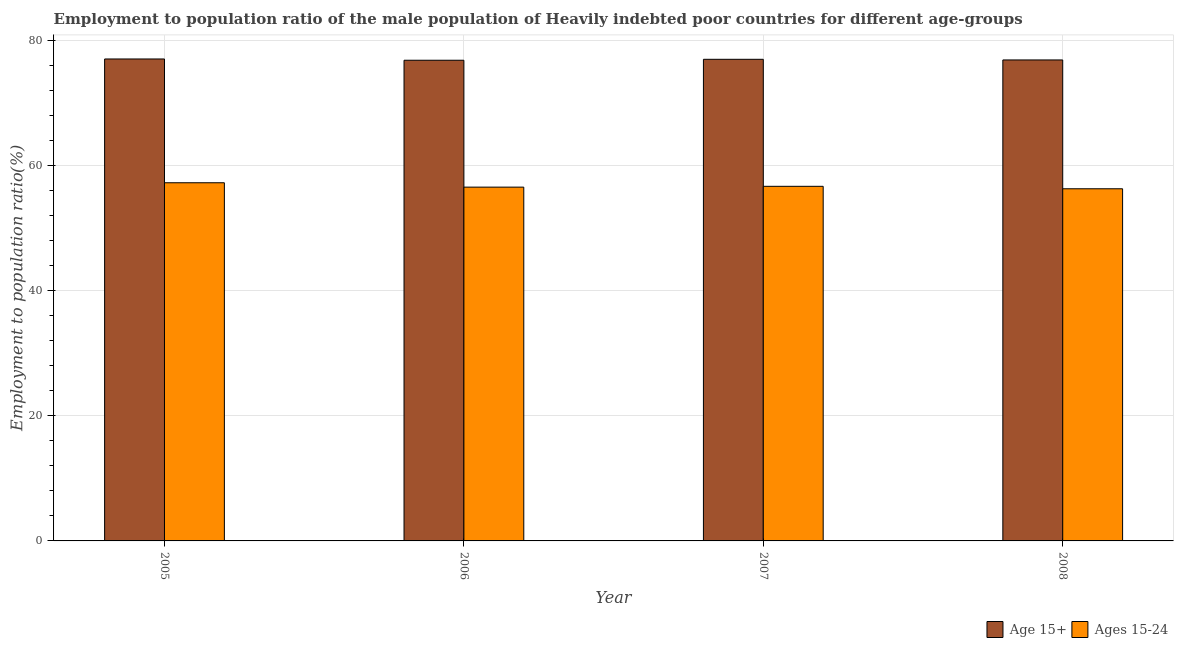Are the number of bars on each tick of the X-axis equal?
Keep it short and to the point. Yes. What is the employment to population ratio(age 15-24) in 2007?
Keep it short and to the point. 56.68. Across all years, what is the maximum employment to population ratio(age 15-24)?
Offer a very short reply. 57.25. Across all years, what is the minimum employment to population ratio(age 15-24)?
Offer a very short reply. 56.28. What is the total employment to population ratio(age 15+) in the graph?
Your answer should be compact. 307.71. What is the difference between the employment to population ratio(age 15+) in 2006 and that in 2008?
Your answer should be compact. -0.05. What is the difference between the employment to population ratio(age 15+) in 2008 and the employment to population ratio(age 15-24) in 2007?
Offer a very short reply. -0.1. What is the average employment to population ratio(age 15+) per year?
Offer a very short reply. 76.93. In the year 2005, what is the difference between the employment to population ratio(age 15+) and employment to population ratio(age 15-24)?
Keep it short and to the point. 0. What is the ratio of the employment to population ratio(age 15-24) in 2005 to that in 2008?
Your answer should be compact. 1.02. Is the difference between the employment to population ratio(age 15+) in 2006 and 2008 greater than the difference between the employment to population ratio(age 15-24) in 2006 and 2008?
Provide a succinct answer. No. What is the difference between the highest and the second highest employment to population ratio(age 15-24)?
Keep it short and to the point. 0.57. What is the difference between the highest and the lowest employment to population ratio(age 15-24)?
Ensure brevity in your answer.  0.96. What does the 1st bar from the left in 2007 represents?
Your answer should be very brief. Age 15+. What does the 1st bar from the right in 2006 represents?
Your answer should be compact. Ages 15-24. How many years are there in the graph?
Provide a succinct answer. 4. What is the difference between two consecutive major ticks on the Y-axis?
Make the answer very short. 20. Are the values on the major ticks of Y-axis written in scientific E-notation?
Offer a terse response. No. Does the graph contain any zero values?
Keep it short and to the point. No. Does the graph contain grids?
Keep it short and to the point. Yes. How are the legend labels stacked?
Offer a terse response. Horizontal. What is the title of the graph?
Make the answer very short. Employment to population ratio of the male population of Heavily indebted poor countries for different age-groups. What is the label or title of the Y-axis?
Your response must be concise. Employment to population ratio(%). What is the Employment to population ratio(%) of Age 15+ in 2005?
Ensure brevity in your answer.  77.03. What is the Employment to population ratio(%) of Ages 15-24 in 2005?
Provide a succinct answer. 57.25. What is the Employment to population ratio(%) of Age 15+ in 2006?
Give a very brief answer. 76.83. What is the Employment to population ratio(%) of Ages 15-24 in 2006?
Give a very brief answer. 56.55. What is the Employment to population ratio(%) in Age 15+ in 2007?
Keep it short and to the point. 76.98. What is the Employment to population ratio(%) in Ages 15-24 in 2007?
Offer a terse response. 56.68. What is the Employment to population ratio(%) in Age 15+ in 2008?
Offer a terse response. 76.87. What is the Employment to population ratio(%) of Ages 15-24 in 2008?
Offer a very short reply. 56.28. Across all years, what is the maximum Employment to population ratio(%) in Age 15+?
Offer a terse response. 77.03. Across all years, what is the maximum Employment to population ratio(%) of Ages 15-24?
Make the answer very short. 57.25. Across all years, what is the minimum Employment to population ratio(%) of Age 15+?
Give a very brief answer. 76.83. Across all years, what is the minimum Employment to population ratio(%) of Ages 15-24?
Your answer should be very brief. 56.28. What is the total Employment to population ratio(%) of Age 15+ in the graph?
Make the answer very short. 307.71. What is the total Employment to population ratio(%) of Ages 15-24 in the graph?
Your response must be concise. 226.75. What is the difference between the Employment to population ratio(%) in Age 15+ in 2005 and that in 2006?
Make the answer very short. 0.2. What is the difference between the Employment to population ratio(%) in Ages 15-24 in 2005 and that in 2006?
Your answer should be very brief. 0.7. What is the difference between the Employment to population ratio(%) of Age 15+ in 2005 and that in 2007?
Your answer should be very brief. 0.05. What is the difference between the Employment to population ratio(%) in Ages 15-24 in 2005 and that in 2007?
Offer a terse response. 0.57. What is the difference between the Employment to population ratio(%) in Age 15+ in 2005 and that in 2008?
Your response must be concise. 0.16. What is the difference between the Employment to population ratio(%) in Ages 15-24 in 2005 and that in 2008?
Provide a succinct answer. 0.96. What is the difference between the Employment to population ratio(%) of Age 15+ in 2006 and that in 2007?
Offer a very short reply. -0.15. What is the difference between the Employment to population ratio(%) of Ages 15-24 in 2006 and that in 2007?
Ensure brevity in your answer.  -0.13. What is the difference between the Employment to population ratio(%) in Age 15+ in 2006 and that in 2008?
Provide a short and direct response. -0.05. What is the difference between the Employment to population ratio(%) in Ages 15-24 in 2006 and that in 2008?
Ensure brevity in your answer.  0.26. What is the difference between the Employment to population ratio(%) of Age 15+ in 2007 and that in 2008?
Keep it short and to the point. 0.1. What is the difference between the Employment to population ratio(%) in Ages 15-24 in 2007 and that in 2008?
Your response must be concise. 0.39. What is the difference between the Employment to population ratio(%) of Age 15+ in 2005 and the Employment to population ratio(%) of Ages 15-24 in 2006?
Offer a terse response. 20.48. What is the difference between the Employment to population ratio(%) of Age 15+ in 2005 and the Employment to population ratio(%) of Ages 15-24 in 2007?
Give a very brief answer. 20.35. What is the difference between the Employment to population ratio(%) in Age 15+ in 2005 and the Employment to population ratio(%) in Ages 15-24 in 2008?
Keep it short and to the point. 20.75. What is the difference between the Employment to population ratio(%) in Age 15+ in 2006 and the Employment to population ratio(%) in Ages 15-24 in 2007?
Provide a short and direct response. 20.15. What is the difference between the Employment to population ratio(%) in Age 15+ in 2006 and the Employment to population ratio(%) in Ages 15-24 in 2008?
Your answer should be very brief. 20.55. What is the difference between the Employment to population ratio(%) of Age 15+ in 2007 and the Employment to population ratio(%) of Ages 15-24 in 2008?
Your answer should be compact. 20.69. What is the average Employment to population ratio(%) of Age 15+ per year?
Your answer should be compact. 76.93. What is the average Employment to population ratio(%) in Ages 15-24 per year?
Offer a very short reply. 56.69. In the year 2005, what is the difference between the Employment to population ratio(%) of Age 15+ and Employment to population ratio(%) of Ages 15-24?
Your response must be concise. 19.78. In the year 2006, what is the difference between the Employment to population ratio(%) of Age 15+ and Employment to population ratio(%) of Ages 15-24?
Offer a very short reply. 20.28. In the year 2007, what is the difference between the Employment to population ratio(%) in Age 15+ and Employment to population ratio(%) in Ages 15-24?
Your response must be concise. 20.3. In the year 2008, what is the difference between the Employment to population ratio(%) of Age 15+ and Employment to population ratio(%) of Ages 15-24?
Give a very brief answer. 20.59. What is the ratio of the Employment to population ratio(%) in Age 15+ in 2005 to that in 2006?
Your response must be concise. 1. What is the ratio of the Employment to population ratio(%) of Ages 15-24 in 2005 to that in 2006?
Give a very brief answer. 1.01. What is the ratio of the Employment to population ratio(%) of Age 15+ in 2005 to that in 2007?
Your answer should be compact. 1. What is the ratio of the Employment to population ratio(%) in Ages 15-24 in 2005 to that in 2007?
Provide a succinct answer. 1.01. What is the ratio of the Employment to population ratio(%) in Age 15+ in 2005 to that in 2008?
Keep it short and to the point. 1. What is the ratio of the Employment to population ratio(%) in Ages 15-24 in 2005 to that in 2008?
Provide a succinct answer. 1.02. What is the ratio of the Employment to population ratio(%) in Ages 15-24 in 2006 to that in 2007?
Give a very brief answer. 1. What is the ratio of the Employment to population ratio(%) of Ages 15-24 in 2006 to that in 2008?
Offer a very short reply. 1. What is the ratio of the Employment to population ratio(%) of Age 15+ in 2007 to that in 2008?
Your answer should be very brief. 1. What is the difference between the highest and the second highest Employment to population ratio(%) in Age 15+?
Keep it short and to the point. 0.05. What is the difference between the highest and the second highest Employment to population ratio(%) of Ages 15-24?
Offer a terse response. 0.57. What is the difference between the highest and the lowest Employment to population ratio(%) in Age 15+?
Keep it short and to the point. 0.2. What is the difference between the highest and the lowest Employment to population ratio(%) in Ages 15-24?
Offer a very short reply. 0.96. 